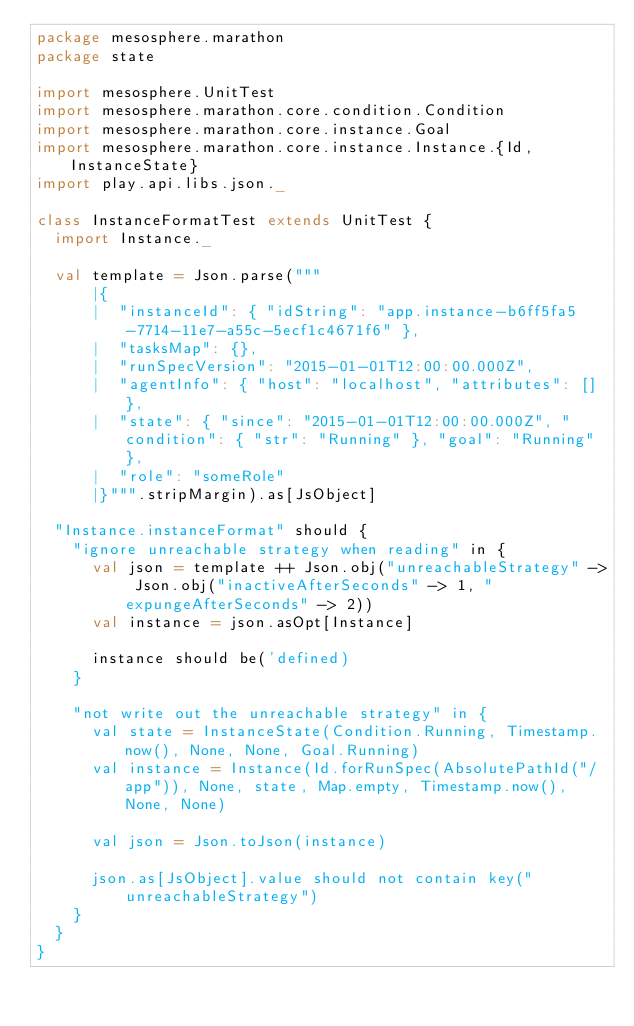Convert code to text. <code><loc_0><loc_0><loc_500><loc_500><_Scala_>package mesosphere.marathon
package state

import mesosphere.UnitTest
import mesosphere.marathon.core.condition.Condition
import mesosphere.marathon.core.instance.Goal
import mesosphere.marathon.core.instance.Instance.{Id, InstanceState}
import play.api.libs.json._

class InstanceFormatTest extends UnitTest {
  import Instance._

  val template = Json.parse("""
      |{
      |  "instanceId": { "idString": "app.instance-b6ff5fa5-7714-11e7-a55c-5ecf1c4671f6" },
      |  "tasksMap": {},
      |  "runSpecVersion": "2015-01-01T12:00:00.000Z",
      |  "agentInfo": { "host": "localhost", "attributes": [] },
      |  "state": { "since": "2015-01-01T12:00:00.000Z", "condition": { "str": "Running" }, "goal": "Running" },
      |  "role": "someRole"
      |}""".stripMargin).as[JsObject]

  "Instance.instanceFormat" should {
    "ignore unreachable strategy when reading" in {
      val json = template ++ Json.obj("unreachableStrategy" -> Json.obj("inactiveAfterSeconds" -> 1, "expungeAfterSeconds" -> 2))
      val instance = json.asOpt[Instance]

      instance should be('defined)
    }

    "not write out the unreachable strategy" in {
      val state = InstanceState(Condition.Running, Timestamp.now(), None, None, Goal.Running)
      val instance = Instance(Id.forRunSpec(AbsolutePathId("/app")), None, state, Map.empty, Timestamp.now(), None, None)

      val json = Json.toJson(instance)

      json.as[JsObject].value should not contain key("unreachableStrategy")
    }
  }
}
</code> 